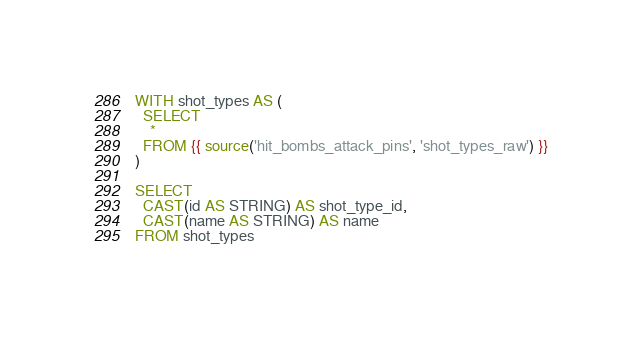<code> <loc_0><loc_0><loc_500><loc_500><_SQL_>WITH shot_types AS (
  SELECT
    *
  FROM {{ source('hit_bombs_attack_pins', 'shot_types_raw') }}
)

SELECT
  CAST(id AS STRING) AS shot_type_id,
  CAST(name AS STRING) AS name
FROM shot_types
</code> 